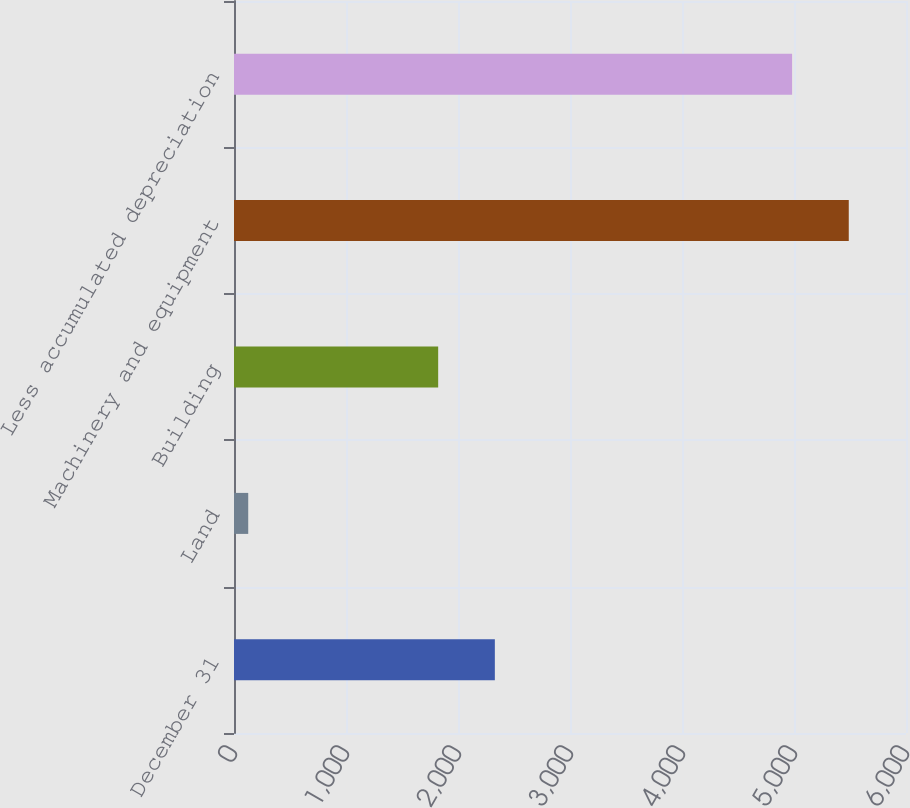<chart> <loc_0><loc_0><loc_500><loc_500><bar_chart><fcel>December 31<fcel>Land<fcel>Building<fcel>Machinery and equipment<fcel>Less accumulated depreciation<nl><fcel>2329<fcel>127<fcel>1823<fcel>5489<fcel>4983<nl></chart> 